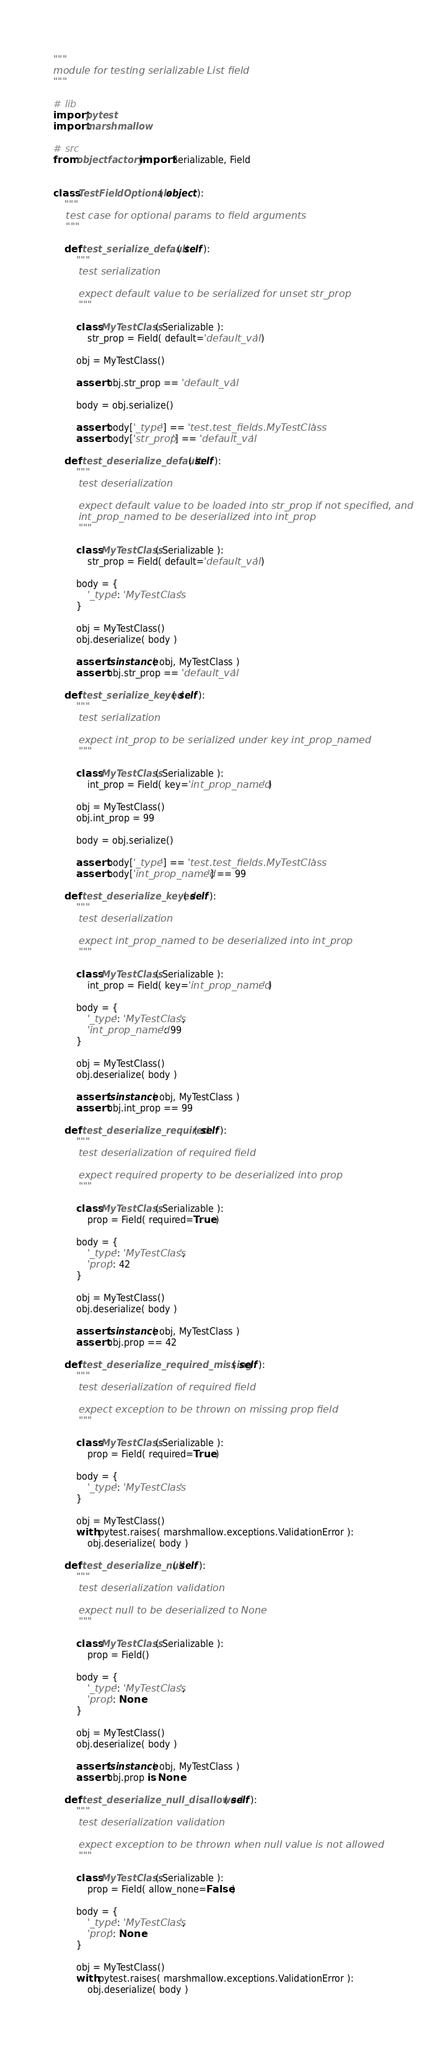Convert code to text. <code><loc_0><loc_0><loc_500><loc_500><_Python_>"""
module for testing serializable List field
"""

# lib
import pytest
import marshmallow

# src
from objectfactory import Serializable, Field


class TestFieldOptionals( object ):
    """
    test case for optional params to field arguments
    """

    def test_serialize_default( self ):
        """
        test serialization

        expect default value to be serialized for unset str_prop
        """

        class MyTestClass( Serializable ):
            str_prop = Field( default='default_val' )

        obj = MyTestClass()

        assert obj.str_prop == 'default_val'

        body = obj.serialize()

        assert body['_type'] == 'test.test_fields.MyTestClass'
        assert body['str_prop'] == 'default_val'

    def test_deserialize_default( self ):
        """
        test deserialization

        expect default value to be loaded into str_prop if not specified, and
        int_prop_named to be deserialized into int_prop
        """

        class MyTestClass( Serializable ):
            str_prop = Field( default='default_val' )

        body = {
            '_type': 'MyTestClass'
        }

        obj = MyTestClass()
        obj.deserialize( body )

        assert isinstance( obj, MyTestClass )
        assert obj.str_prop == 'default_val'

    def test_serialize_keyed( self ):
        """
        test serialization

        expect int_prop to be serialized under key int_prop_named
        """

        class MyTestClass( Serializable ):
            int_prop = Field( key='int_prop_named' )

        obj = MyTestClass()
        obj.int_prop = 99

        body = obj.serialize()

        assert body['_type'] == 'test.test_fields.MyTestClass'
        assert body['int_prop_named'] == 99

    def test_deserialize_keyed( self ):
        """
        test deserialization

        expect int_prop_named to be deserialized into int_prop
        """

        class MyTestClass( Serializable ):
            int_prop = Field( key='int_prop_named' )

        body = {
            '_type': 'MyTestClass',
            'int_prop_named': 99
        }

        obj = MyTestClass()
        obj.deserialize( body )

        assert isinstance( obj, MyTestClass )
        assert obj.int_prop == 99

    def test_deserialize_required( self ):
        """
        test deserialization of required field

        expect required property to be deserialized into prop
        """

        class MyTestClass( Serializable ):
            prop = Field( required=True )

        body = {
            '_type': 'MyTestClass',
            'prop': 42
        }

        obj = MyTestClass()
        obj.deserialize( body )

        assert isinstance( obj, MyTestClass )
        assert obj.prop == 42

    def test_deserialize_required_missing( self ):
        """
        test deserialization of required field

        expect exception to be thrown on missing prop field
        """

        class MyTestClass( Serializable ):
            prop = Field( required=True )

        body = {
            '_type': 'MyTestClass'
        }

        obj = MyTestClass()
        with pytest.raises( marshmallow.exceptions.ValidationError ):
            obj.deserialize( body )

    def test_deserialize_null( self ):
        """
        test deserialization validation

        expect null to be deserialized to None
        """

        class MyTestClass( Serializable ):
            prop = Field()

        body = {
            '_type': 'MyTestClass',
            'prop': None
        }

        obj = MyTestClass()
        obj.deserialize( body )

        assert isinstance( obj, MyTestClass )
        assert obj.prop is None

    def test_deserialize_null_disallowed( self ):
        """
        test deserialization validation

        expect exception to be thrown when null value is not allowed
        """

        class MyTestClass( Serializable ):
            prop = Field( allow_none=False )

        body = {
            '_type': 'MyTestClass',
            'prop': None
        }

        obj = MyTestClass()
        with pytest.raises( marshmallow.exceptions.ValidationError ):
            obj.deserialize( body )
</code> 